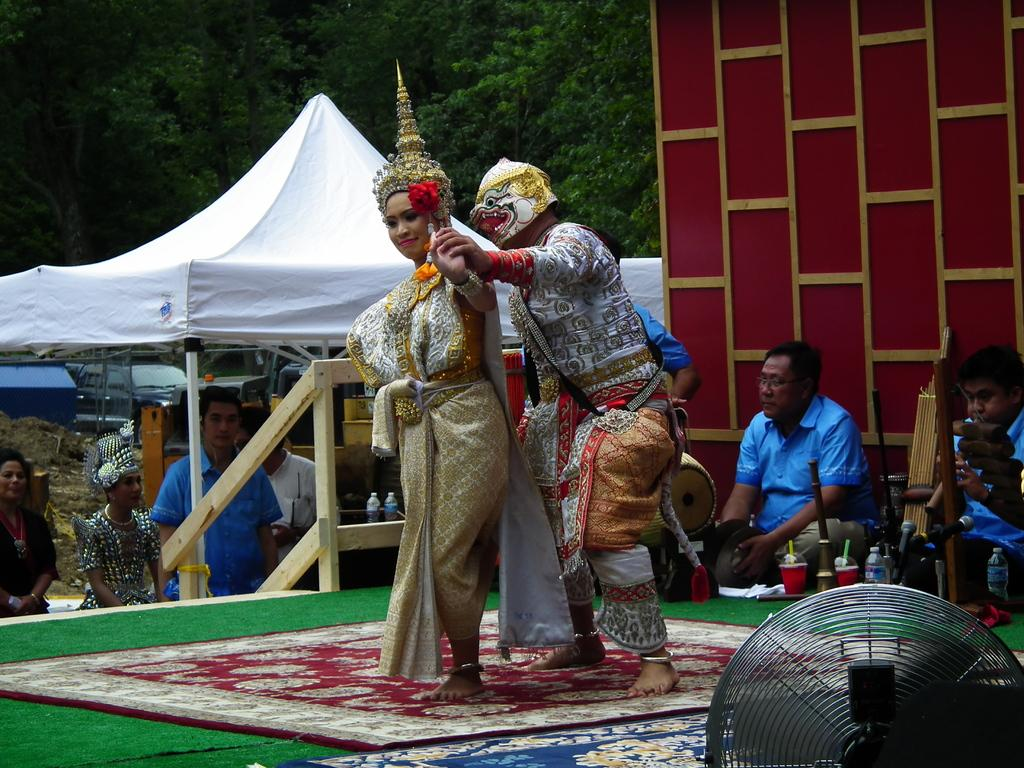How many people are standing in the image? There are two people standing in the image. What are the colors of the dresses worn by the standing people? One person is wearing a white dress, and the other is wearing a gold dress. What are the people in the background doing? The people in the background are playing drums. What color is the cloth visible in the background? The cloth visible in the background is maroon-colored. What type of stone is being used to make the soda in the image? There is no stone or soda present in the image; it features two people standing and people in the background playing drums. 